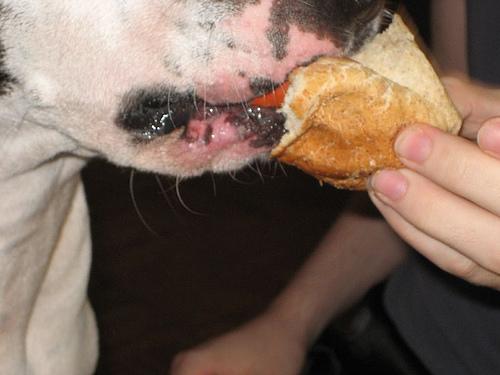What color is the dog's nose?
Answer briefly. Black. Does the dog like the food?
Keep it brief. Yes. What kind of creature is the person feeding?
Write a very short answer. Dog. What color is the dog's fur?
Write a very short answer. White. 